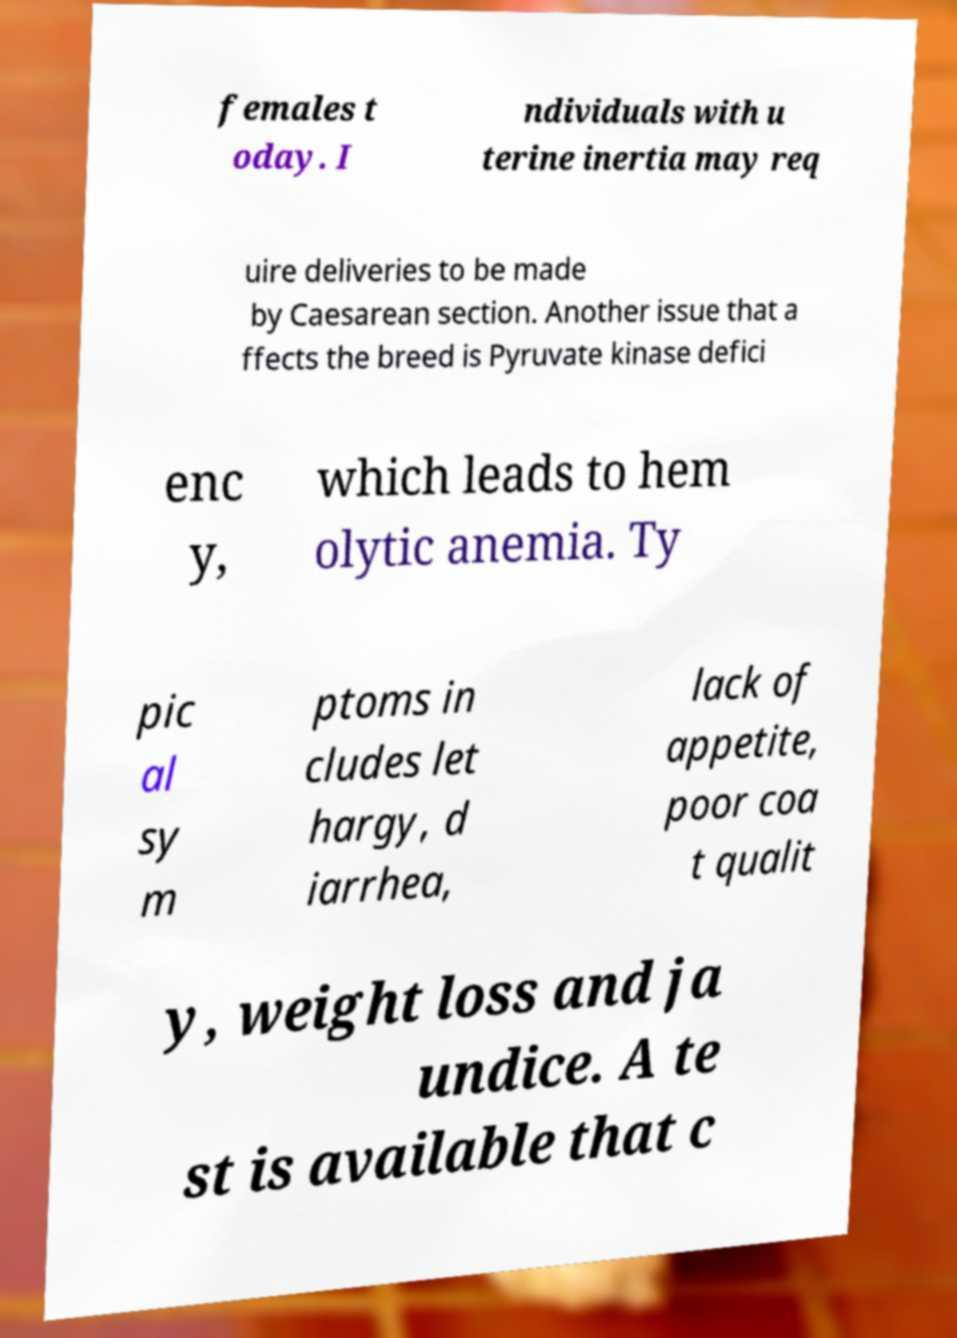There's text embedded in this image that I need extracted. Can you transcribe it verbatim? females t oday. I ndividuals with u terine inertia may req uire deliveries to be made by Caesarean section. Another issue that a ffects the breed is Pyruvate kinase defici enc y, which leads to hem olytic anemia. Ty pic al sy m ptoms in cludes let hargy, d iarrhea, lack of appetite, poor coa t qualit y, weight loss and ja undice. A te st is available that c 